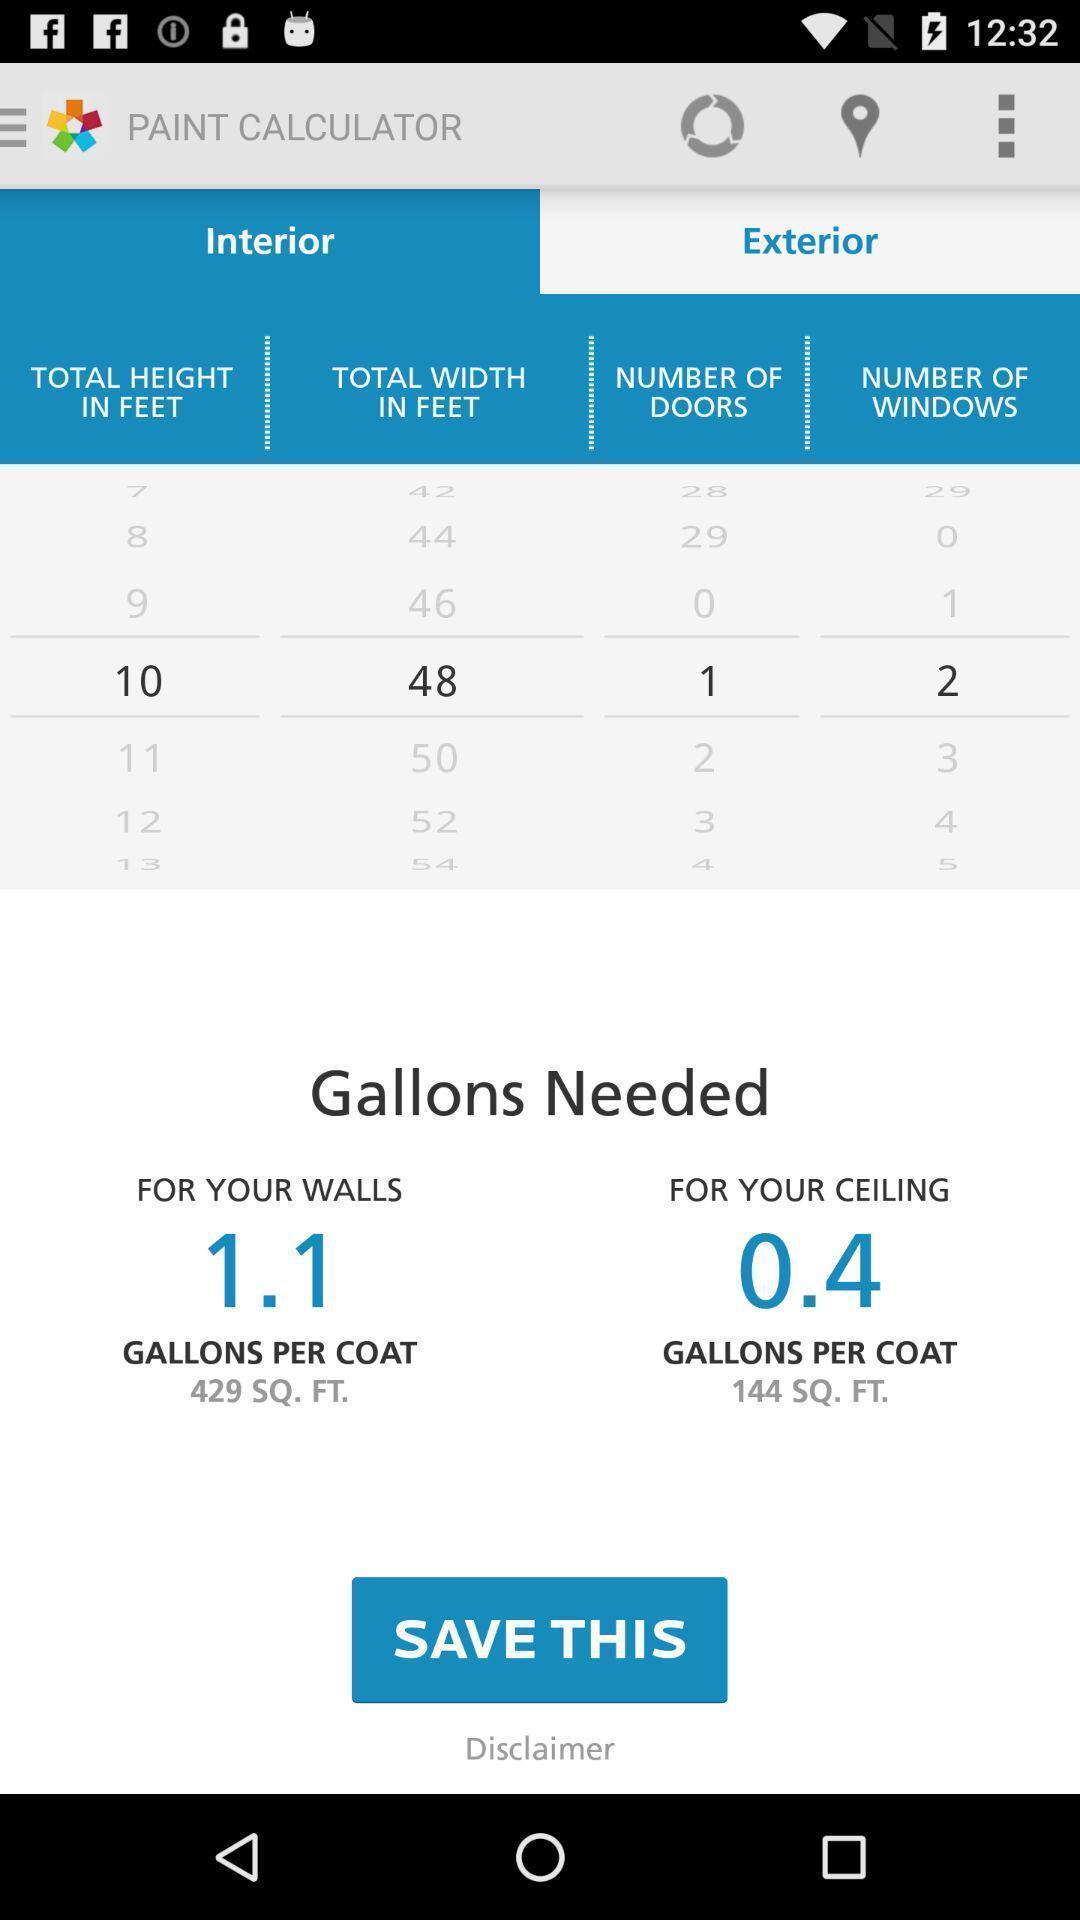Describe the key features of this screenshot. Screen shows about a paint calculator. 